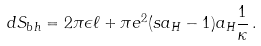<formula> <loc_0><loc_0><loc_500><loc_500>d S _ { b h } = 2 \pi \epsilon \ell + \pi e ^ { 2 } ( s a _ { H } - 1 ) a _ { H } \frac { 1 } { \kappa } \, .</formula> 